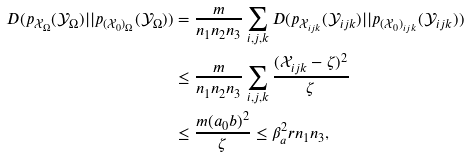Convert formula to latex. <formula><loc_0><loc_0><loc_500><loc_500>D ( p _ { \mathcal { X } _ { \Omega } } ( \mathcal { Y } _ { \Omega } ) | | p _ { ( \mathcal { X } _ { 0 } ) _ { \Omega } } ( \mathcal { Y } _ { \Omega } ) ) & = \frac { m } { n _ { 1 } n _ { 2 } n _ { 3 } } \sum _ { i , j , k } D ( p _ { \mathcal { X } _ { i j k } } ( \mathcal { Y } _ { i j k } ) | | p _ { ( \mathcal { X } _ { 0 } ) _ { i j k } } ( \mathcal { Y } _ { i j k } ) ) \\ & \leq \frac { m } { n _ { 1 } n _ { 2 } n _ { 3 } } \sum _ { i , j , k } \frac { ( \mathcal { X } _ { i j k } - \zeta ) ^ { 2 } } { \zeta } \\ & \leq \frac { m ( a _ { 0 } b ) ^ { 2 } } { \zeta } \leq \beta _ { a } ^ { 2 } r n _ { 1 } n _ { 3 } ,</formula> 